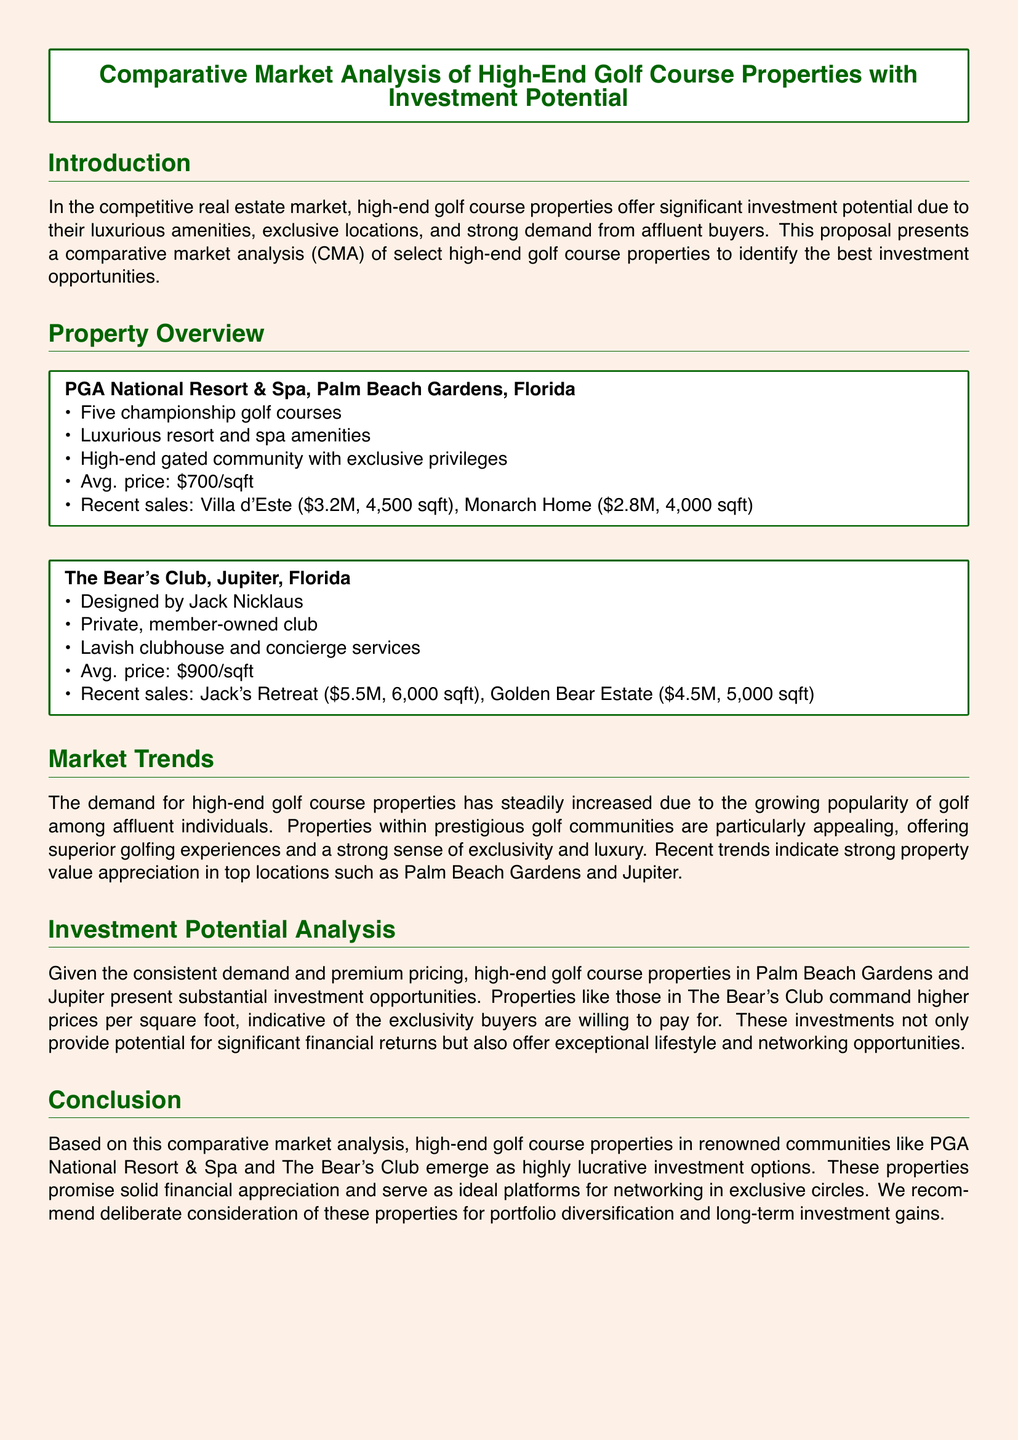What is the average price per square foot for PGA National Resort & Spa? The average price per square foot for PGA National Resort & Spa is mentioned in the Property Overview section.
Answer: $700/sqft What are the recent sales in The Bear's Club? The recent sales for The Bear's Club are listed in the Property Overview section.
Answer: Jack's Retreat ($5.5M, 6,000 sqft), Golden Bear Estate ($4.5M, 5,000 sqft) Which designer is associated with The Bear's Club? The designer of The Bear's Club is specified in the Property Overview.
Answer: Jack Nicklaus What is the primary trend in high-end golf course property demand? The document discusses growth aspects in the Market Trends section.
Answer: Steadily increased What two benefits do high-end golf course properties provide? The Investment Potential Analysis section highlights key advantages of these properties.
Answer: Financial returns, lifestyle and networking opportunities What community is mentioned alongside PGA National Resort & Spa? The conclusion mentions another community that is highlighted in the proposal.
Answer: The Bear's Club What is the focus of this proposal? The document overall focuses on a specific aspect related to high-end golf course properties.
Answer: Comparative market analysis What does the proposal recommend for portfolio diversification? The conclusion contains recommendations based on the analysis presented.
Answer: High-end golf course properties 